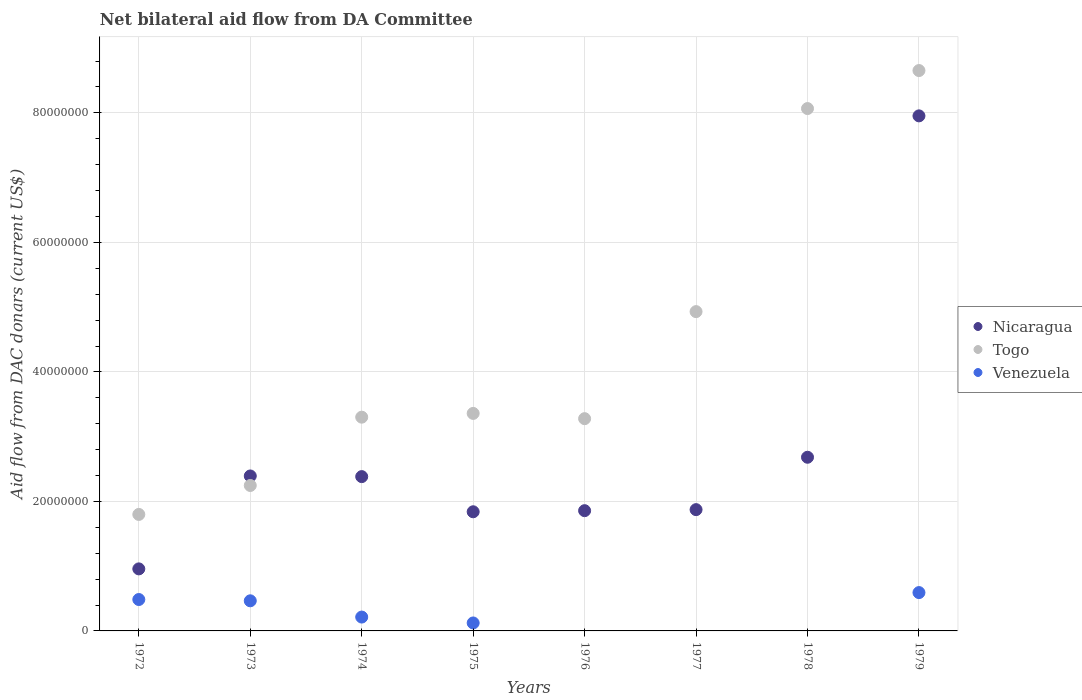Is the number of dotlines equal to the number of legend labels?
Provide a short and direct response. No. What is the aid flow in in Nicaragua in 1975?
Provide a succinct answer. 1.84e+07. Across all years, what is the maximum aid flow in in Nicaragua?
Provide a short and direct response. 7.95e+07. Across all years, what is the minimum aid flow in in Venezuela?
Your answer should be very brief. 0. In which year was the aid flow in in Nicaragua maximum?
Provide a short and direct response. 1979. What is the total aid flow in in Togo in the graph?
Your response must be concise. 3.56e+08. What is the difference between the aid flow in in Togo in 1972 and that in 1976?
Offer a very short reply. -1.48e+07. What is the difference between the aid flow in in Venezuela in 1979 and the aid flow in in Togo in 1972?
Your answer should be very brief. -1.21e+07. What is the average aid flow in in Venezuela per year?
Offer a very short reply. 2.35e+06. In the year 1976, what is the difference between the aid flow in in Togo and aid flow in in Nicaragua?
Give a very brief answer. 1.42e+07. What is the ratio of the aid flow in in Nicaragua in 1973 to that in 1975?
Keep it short and to the point. 1.3. Is the aid flow in in Togo in 1976 less than that in 1977?
Your answer should be compact. Yes. What is the difference between the highest and the second highest aid flow in in Nicaragua?
Provide a short and direct response. 5.27e+07. What is the difference between the highest and the lowest aid flow in in Togo?
Your answer should be compact. 6.86e+07. In how many years, is the aid flow in in Venezuela greater than the average aid flow in in Venezuela taken over all years?
Keep it short and to the point. 3. Is it the case that in every year, the sum of the aid flow in in Venezuela and aid flow in in Nicaragua  is greater than the aid flow in in Togo?
Your response must be concise. No. Does the aid flow in in Venezuela monotonically increase over the years?
Your answer should be compact. No. Is the aid flow in in Venezuela strictly greater than the aid flow in in Nicaragua over the years?
Ensure brevity in your answer.  No. How many dotlines are there?
Offer a terse response. 3. How many years are there in the graph?
Offer a terse response. 8. What is the difference between two consecutive major ticks on the Y-axis?
Give a very brief answer. 2.00e+07. Are the values on the major ticks of Y-axis written in scientific E-notation?
Keep it short and to the point. No. How are the legend labels stacked?
Ensure brevity in your answer.  Vertical. What is the title of the graph?
Keep it short and to the point. Net bilateral aid flow from DA Committee. Does "Lao PDR" appear as one of the legend labels in the graph?
Your answer should be compact. No. What is the label or title of the X-axis?
Ensure brevity in your answer.  Years. What is the label or title of the Y-axis?
Give a very brief answer. Aid flow from DAC donars (current US$). What is the Aid flow from DAC donars (current US$) in Nicaragua in 1972?
Make the answer very short. 9.58e+06. What is the Aid flow from DAC donars (current US$) in Togo in 1972?
Provide a succinct answer. 1.80e+07. What is the Aid flow from DAC donars (current US$) in Venezuela in 1972?
Provide a succinct answer. 4.85e+06. What is the Aid flow from DAC donars (current US$) in Nicaragua in 1973?
Ensure brevity in your answer.  2.39e+07. What is the Aid flow from DAC donars (current US$) of Togo in 1973?
Keep it short and to the point. 2.25e+07. What is the Aid flow from DAC donars (current US$) in Venezuela in 1973?
Give a very brief answer. 4.65e+06. What is the Aid flow from DAC donars (current US$) of Nicaragua in 1974?
Your answer should be very brief. 2.38e+07. What is the Aid flow from DAC donars (current US$) of Togo in 1974?
Give a very brief answer. 3.30e+07. What is the Aid flow from DAC donars (current US$) of Venezuela in 1974?
Make the answer very short. 2.14e+06. What is the Aid flow from DAC donars (current US$) of Nicaragua in 1975?
Your answer should be compact. 1.84e+07. What is the Aid flow from DAC donars (current US$) in Togo in 1975?
Provide a short and direct response. 3.36e+07. What is the Aid flow from DAC donars (current US$) in Venezuela in 1975?
Make the answer very short. 1.23e+06. What is the Aid flow from DAC donars (current US$) of Nicaragua in 1976?
Give a very brief answer. 1.86e+07. What is the Aid flow from DAC donars (current US$) of Togo in 1976?
Offer a very short reply. 3.28e+07. What is the Aid flow from DAC donars (current US$) in Venezuela in 1976?
Keep it short and to the point. 0. What is the Aid flow from DAC donars (current US$) of Nicaragua in 1977?
Your answer should be very brief. 1.87e+07. What is the Aid flow from DAC donars (current US$) in Togo in 1977?
Ensure brevity in your answer.  4.93e+07. What is the Aid flow from DAC donars (current US$) in Venezuela in 1977?
Offer a terse response. 0. What is the Aid flow from DAC donars (current US$) in Nicaragua in 1978?
Give a very brief answer. 2.68e+07. What is the Aid flow from DAC donars (current US$) of Togo in 1978?
Your answer should be compact. 8.07e+07. What is the Aid flow from DAC donars (current US$) of Venezuela in 1978?
Provide a short and direct response. 0. What is the Aid flow from DAC donars (current US$) of Nicaragua in 1979?
Provide a succinct answer. 7.95e+07. What is the Aid flow from DAC donars (current US$) in Togo in 1979?
Offer a very short reply. 8.65e+07. What is the Aid flow from DAC donars (current US$) in Venezuela in 1979?
Provide a short and direct response. 5.92e+06. Across all years, what is the maximum Aid flow from DAC donars (current US$) in Nicaragua?
Provide a succinct answer. 7.95e+07. Across all years, what is the maximum Aid flow from DAC donars (current US$) in Togo?
Your answer should be compact. 8.65e+07. Across all years, what is the maximum Aid flow from DAC donars (current US$) in Venezuela?
Provide a succinct answer. 5.92e+06. Across all years, what is the minimum Aid flow from DAC donars (current US$) in Nicaragua?
Your answer should be very brief. 9.58e+06. Across all years, what is the minimum Aid flow from DAC donars (current US$) of Togo?
Make the answer very short. 1.80e+07. Across all years, what is the minimum Aid flow from DAC donars (current US$) in Venezuela?
Offer a very short reply. 0. What is the total Aid flow from DAC donars (current US$) in Nicaragua in the graph?
Provide a short and direct response. 2.19e+08. What is the total Aid flow from DAC donars (current US$) of Togo in the graph?
Your answer should be very brief. 3.56e+08. What is the total Aid flow from DAC donars (current US$) in Venezuela in the graph?
Provide a short and direct response. 1.88e+07. What is the difference between the Aid flow from DAC donars (current US$) in Nicaragua in 1972 and that in 1973?
Your response must be concise. -1.44e+07. What is the difference between the Aid flow from DAC donars (current US$) of Togo in 1972 and that in 1973?
Your answer should be very brief. -4.47e+06. What is the difference between the Aid flow from DAC donars (current US$) of Nicaragua in 1972 and that in 1974?
Your answer should be compact. -1.42e+07. What is the difference between the Aid flow from DAC donars (current US$) in Togo in 1972 and that in 1974?
Your response must be concise. -1.50e+07. What is the difference between the Aid flow from DAC donars (current US$) of Venezuela in 1972 and that in 1974?
Offer a very short reply. 2.71e+06. What is the difference between the Aid flow from DAC donars (current US$) of Nicaragua in 1972 and that in 1975?
Your response must be concise. -8.82e+06. What is the difference between the Aid flow from DAC donars (current US$) in Togo in 1972 and that in 1975?
Keep it short and to the point. -1.56e+07. What is the difference between the Aid flow from DAC donars (current US$) in Venezuela in 1972 and that in 1975?
Your answer should be compact. 3.62e+06. What is the difference between the Aid flow from DAC donars (current US$) of Nicaragua in 1972 and that in 1976?
Keep it short and to the point. -8.99e+06. What is the difference between the Aid flow from DAC donars (current US$) in Togo in 1972 and that in 1976?
Make the answer very short. -1.48e+07. What is the difference between the Aid flow from DAC donars (current US$) in Nicaragua in 1972 and that in 1977?
Your response must be concise. -9.15e+06. What is the difference between the Aid flow from DAC donars (current US$) in Togo in 1972 and that in 1977?
Your answer should be compact. -3.13e+07. What is the difference between the Aid flow from DAC donars (current US$) of Nicaragua in 1972 and that in 1978?
Give a very brief answer. -1.72e+07. What is the difference between the Aid flow from DAC donars (current US$) of Togo in 1972 and that in 1978?
Give a very brief answer. -6.27e+07. What is the difference between the Aid flow from DAC donars (current US$) in Nicaragua in 1972 and that in 1979?
Provide a short and direct response. -7.00e+07. What is the difference between the Aid flow from DAC donars (current US$) in Togo in 1972 and that in 1979?
Your answer should be very brief. -6.86e+07. What is the difference between the Aid flow from DAC donars (current US$) of Venezuela in 1972 and that in 1979?
Your response must be concise. -1.07e+06. What is the difference between the Aid flow from DAC donars (current US$) of Nicaragua in 1973 and that in 1974?
Ensure brevity in your answer.  1.00e+05. What is the difference between the Aid flow from DAC donars (current US$) of Togo in 1973 and that in 1974?
Ensure brevity in your answer.  -1.06e+07. What is the difference between the Aid flow from DAC donars (current US$) in Venezuela in 1973 and that in 1974?
Provide a short and direct response. 2.51e+06. What is the difference between the Aid flow from DAC donars (current US$) in Nicaragua in 1973 and that in 1975?
Ensure brevity in your answer.  5.53e+06. What is the difference between the Aid flow from DAC donars (current US$) in Togo in 1973 and that in 1975?
Your response must be concise. -1.11e+07. What is the difference between the Aid flow from DAC donars (current US$) in Venezuela in 1973 and that in 1975?
Your answer should be compact. 3.42e+06. What is the difference between the Aid flow from DAC donars (current US$) in Nicaragua in 1973 and that in 1976?
Your answer should be very brief. 5.36e+06. What is the difference between the Aid flow from DAC donars (current US$) in Togo in 1973 and that in 1976?
Your answer should be compact. -1.03e+07. What is the difference between the Aid flow from DAC donars (current US$) in Nicaragua in 1973 and that in 1977?
Offer a very short reply. 5.20e+06. What is the difference between the Aid flow from DAC donars (current US$) of Togo in 1973 and that in 1977?
Provide a succinct answer. -2.68e+07. What is the difference between the Aid flow from DAC donars (current US$) of Nicaragua in 1973 and that in 1978?
Provide a short and direct response. -2.89e+06. What is the difference between the Aid flow from DAC donars (current US$) of Togo in 1973 and that in 1978?
Your answer should be compact. -5.82e+07. What is the difference between the Aid flow from DAC donars (current US$) in Nicaragua in 1973 and that in 1979?
Your response must be concise. -5.56e+07. What is the difference between the Aid flow from DAC donars (current US$) in Togo in 1973 and that in 1979?
Make the answer very short. -6.41e+07. What is the difference between the Aid flow from DAC donars (current US$) of Venezuela in 1973 and that in 1979?
Keep it short and to the point. -1.27e+06. What is the difference between the Aid flow from DAC donars (current US$) of Nicaragua in 1974 and that in 1975?
Provide a succinct answer. 5.43e+06. What is the difference between the Aid flow from DAC donars (current US$) in Togo in 1974 and that in 1975?
Offer a very short reply. -5.80e+05. What is the difference between the Aid flow from DAC donars (current US$) of Venezuela in 1974 and that in 1975?
Make the answer very short. 9.10e+05. What is the difference between the Aid flow from DAC donars (current US$) in Nicaragua in 1974 and that in 1976?
Keep it short and to the point. 5.26e+06. What is the difference between the Aid flow from DAC donars (current US$) in Nicaragua in 1974 and that in 1977?
Keep it short and to the point. 5.10e+06. What is the difference between the Aid flow from DAC donars (current US$) in Togo in 1974 and that in 1977?
Keep it short and to the point. -1.63e+07. What is the difference between the Aid flow from DAC donars (current US$) in Nicaragua in 1974 and that in 1978?
Offer a terse response. -2.99e+06. What is the difference between the Aid flow from DAC donars (current US$) in Togo in 1974 and that in 1978?
Keep it short and to the point. -4.77e+07. What is the difference between the Aid flow from DAC donars (current US$) in Nicaragua in 1974 and that in 1979?
Your answer should be very brief. -5.57e+07. What is the difference between the Aid flow from DAC donars (current US$) of Togo in 1974 and that in 1979?
Your response must be concise. -5.35e+07. What is the difference between the Aid flow from DAC donars (current US$) in Venezuela in 1974 and that in 1979?
Your response must be concise. -3.78e+06. What is the difference between the Aid flow from DAC donars (current US$) of Togo in 1975 and that in 1976?
Your answer should be compact. 8.10e+05. What is the difference between the Aid flow from DAC donars (current US$) in Nicaragua in 1975 and that in 1977?
Offer a terse response. -3.30e+05. What is the difference between the Aid flow from DAC donars (current US$) of Togo in 1975 and that in 1977?
Provide a short and direct response. -1.57e+07. What is the difference between the Aid flow from DAC donars (current US$) in Nicaragua in 1975 and that in 1978?
Make the answer very short. -8.42e+06. What is the difference between the Aid flow from DAC donars (current US$) of Togo in 1975 and that in 1978?
Keep it short and to the point. -4.71e+07. What is the difference between the Aid flow from DAC donars (current US$) of Nicaragua in 1975 and that in 1979?
Make the answer very short. -6.11e+07. What is the difference between the Aid flow from DAC donars (current US$) of Togo in 1975 and that in 1979?
Offer a terse response. -5.30e+07. What is the difference between the Aid flow from DAC donars (current US$) in Venezuela in 1975 and that in 1979?
Ensure brevity in your answer.  -4.69e+06. What is the difference between the Aid flow from DAC donars (current US$) of Togo in 1976 and that in 1977?
Make the answer very short. -1.65e+07. What is the difference between the Aid flow from DAC donars (current US$) in Nicaragua in 1976 and that in 1978?
Keep it short and to the point. -8.25e+06. What is the difference between the Aid flow from DAC donars (current US$) of Togo in 1976 and that in 1978?
Provide a short and direct response. -4.79e+07. What is the difference between the Aid flow from DAC donars (current US$) of Nicaragua in 1976 and that in 1979?
Provide a succinct answer. -6.10e+07. What is the difference between the Aid flow from DAC donars (current US$) in Togo in 1976 and that in 1979?
Keep it short and to the point. -5.38e+07. What is the difference between the Aid flow from DAC donars (current US$) in Nicaragua in 1977 and that in 1978?
Your answer should be compact. -8.09e+06. What is the difference between the Aid flow from DAC donars (current US$) in Togo in 1977 and that in 1978?
Ensure brevity in your answer.  -3.14e+07. What is the difference between the Aid flow from DAC donars (current US$) of Nicaragua in 1977 and that in 1979?
Provide a succinct answer. -6.08e+07. What is the difference between the Aid flow from DAC donars (current US$) in Togo in 1977 and that in 1979?
Provide a short and direct response. -3.72e+07. What is the difference between the Aid flow from DAC donars (current US$) of Nicaragua in 1978 and that in 1979?
Offer a very short reply. -5.27e+07. What is the difference between the Aid flow from DAC donars (current US$) of Togo in 1978 and that in 1979?
Your answer should be very brief. -5.87e+06. What is the difference between the Aid flow from DAC donars (current US$) of Nicaragua in 1972 and the Aid flow from DAC donars (current US$) of Togo in 1973?
Give a very brief answer. -1.29e+07. What is the difference between the Aid flow from DAC donars (current US$) in Nicaragua in 1972 and the Aid flow from DAC donars (current US$) in Venezuela in 1973?
Provide a short and direct response. 4.93e+06. What is the difference between the Aid flow from DAC donars (current US$) of Togo in 1972 and the Aid flow from DAC donars (current US$) of Venezuela in 1973?
Offer a terse response. 1.33e+07. What is the difference between the Aid flow from DAC donars (current US$) of Nicaragua in 1972 and the Aid flow from DAC donars (current US$) of Togo in 1974?
Your answer should be compact. -2.34e+07. What is the difference between the Aid flow from DAC donars (current US$) of Nicaragua in 1972 and the Aid flow from DAC donars (current US$) of Venezuela in 1974?
Provide a succinct answer. 7.44e+06. What is the difference between the Aid flow from DAC donars (current US$) in Togo in 1972 and the Aid flow from DAC donars (current US$) in Venezuela in 1974?
Provide a short and direct response. 1.58e+07. What is the difference between the Aid flow from DAC donars (current US$) in Nicaragua in 1972 and the Aid flow from DAC donars (current US$) in Togo in 1975?
Provide a short and direct response. -2.40e+07. What is the difference between the Aid flow from DAC donars (current US$) of Nicaragua in 1972 and the Aid flow from DAC donars (current US$) of Venezuela in 1975?
Provide a succinct answer. 8.35e+06. What is the difference between the Aid flow from DAC donars (current US$) of Togo in 1972 and the Aid flow from DAC donars (current US$) of Venezuela in 1975?
Keep it short and to the point. 1.68e+07. What is the difference between the Aid flow from DAC donars (current US$) of Nicaragua in 1972 and the Aid flow from DAC donars (current US$) of Togo in 1976?
Keep it short and to the point. -2.32e+07. What is the difference between the Aid flow from DAC donars (current US$) in Nicaragua in 1972 and the Aid flow from DAC donars (current US$) in Togo in 1977?
Keep it short and to the point. -3.97e+07. What is the difference between the Aid flow from DAC donars (current US$) in Nicaragua in 1972 and the Aid flow from DAC donars (current US$) in Togo in 1978?
Provide a short and direct response. -7.11e+07. What is the difference between the Aid flow from DAC donars (current US$) of Nicaragua in 1972 and the Aid flow from DAC donars (current US$) of Togo in 1979?
Keep it short and to the point. -7.70e+07. What is the difference between the Aid flow from DAC donars (current US$) in Nicaragua in 1972 and the Aid flow from DAC donars (current US$) in Venezuela in 1979?
Ensure brevity in your answer.  3.66e+06. What is the difference between the Aid flow from DAC donars (current US$) of Togo in 1972 and the Aid flow from DAC donars (current US$) of Venezuela in 1979?
Provide a succinct answer. 1.21e+07. What is the difference between the Aid flow from DAC donars (current US$) of Nicaragua in 1973 and the Aid flow from DAC donars (current US$) of Togo in 1974?
Offer a very short reply. -9.08e+06. What is the difference between the Aid flow from DAC donars (current US$) in Nicaragua in 1973 and the Aid flow from DAC donars (current US$) in Venezuela in 1974?
Your answer should be very brief. 2.18e+07. What is the difference between the Aid flow from DAC donars (current US$) in Togo in 1973 and the Aid flow from DAC donars (current US$) in Venezuela in 1974?
Ensure brevity in your answer.  2.03e+07. What is the difference between the Aid flow from DAC donars (current US$) of Nicaragua in 1973 and the Aid flow from DAC donars (current US$) of Togo in 1975?
Give a very brief answer. -9.66e+06. What is the difference between the Aid flow from DAC donars (current US$) in Nicaragua in 1973 and the Aid flow from DAC donars (current US$) in Venezuela in 1975?
Offer a terse response. 2.27e+07. What is the difference between the Aid flow from DAC donars (current US$) of Togo in 1973 and the Aid flow from DAC donars (current US$) of Venezuela in 1975?
Ensure brevity in your answer.  2.12e+07. What is the difference between the Aid flow from DAC donars (current US$) of Nicaragua in 1973 and the Aid flow from DAC donars (current US$) of Togo in 1976?
Offer a terse response. -8.85e+06. What is the difference between the Aid flow from DAC donars (current US$) of Nicaragua in 1973 and the Aid flow from DAC donars (current US$) of Togo in 1977?
Ensure brevity in your answer.  -2.54e+07. What is the difference between the Aid flow from DAC donars (current US$) of Nicaragua in 1973 and the Aid flow from DAC donars (current US$) of Togo in 1978?
Provide a short and direct response. -5.67e+07. What is the difference between the Aid flow from DAC donars (current US$) in Nicaragua in 1973 and the Aid flow from DAC donars (current US$) in Togo in 1979?
Offer a terse response. -6.26e+07. What is the difference between the Aid flow from DAC donars (current US$) in Nicaragua in 1973 and the Aid flow from DAC donars (current US$) in Venezuela in 1979?
Offer a very short reply. 1.80e+07. What is the difference between the Aid flow from DAC donars (current US$) of Togo in 1973 and the Aid flow from DAC donars (current US$) of Venezuela in 1979?
Offer a very short reply. 1.65e+07. What is the difference between the Aid flow from DAC donars (current US$) in Nicaragua in 1974 and the Aid flow from DAC donars (current US$) in Togo in 1975?
Keep it short and to the point. -9.76e+06. What is the difference between the Aid flow from DAC donars (current US$) in Nicaragua in 1974 and the Aid flow from DAC donars (current US$) in Venezuela in 1975?
Your response must be concise. 2.26e+07. What is the difference between the Aid flow from DAC donars (current US$) in Togo in 1974 and the Aid flow from DAC donars (current US$) in Venezuela in 1975?
Give a very brief answer. 3.18e+07. What is the difference between the Aid flow from DAC donars (current US$) of Nicaragua in 1974 and the Aid flow from DAC donars (current US$) of Togo in 1976?
Your answer should be very brief. -8.95e+06. What is the difference between the Aid flow from DAC donars (current US$) of Nicaragua in 1974 and the Aid flow from DAC donars (current US$) of Togo in 1977?
Your answer should be very brief. -2.55e+07. What is the difference between the Aid flow from DAC donars (current US$) of Nicaragua in 1974 and the Aid flow from DAC donars (current US$) of Togo in 1978?
Your answer should be compact. -5.68e+07. What is the difference between the Aid flow from DAC donars (current US$) of Nicaragua in 1974 and the Aid flow from DAC donars (current US$) of Togo in 1979?
Your answer should be very brief. -6.27e+07. What is the difference between the Aid flow from DAC donars (current US$) in Nicaragua in 1974 and the Aid flow from DAC donars (current US$) in Venezuela in 1979?
Ensure brevity in your answer.  1.79e+07. What is the difference between the Aid flow from DAC donars (current US$) in Togo in 1974 and the Aid flow from DAC donars (current US$) in Venezuela in 1979?
Provide a short and direct response. 2.71e+07. What is the difference between the Aid flow from DAC donars (current US$) of Nicaragua in 1975 and the Aid flow from DAC donars (current US$) of Togo in 1976?
Ensure brevity in your answer.  -1.44e+07. What is the difference between the Aid flow from DAC donars (current US$) in Nicaragua in 1975 and the Aid flow from DAC donars (current US$) in Togo in 1977?
Offer a terse response. -3.09e+07. What is the difference between the Aid flow from DAC donars (current US$) of Nicaragua in 1975 and the Aid flow from DAC donars (current US$) of Togo in 1978?
Provide a short and direct response. -6.23e+07. What is the difference between the Aid flow from DAC donars (current US$) in Nicaragua in 1975 and the Aid flow from DAC donars (current US$) in Togo in 1979?
Your answer should be compact. -6.81e+07. What is the difference between the Aid flow from DAC donars (current US$) in Nicaragua in 1975 and the Aid flow from DAC donars (current US$) in Venezuela in 1979?
Keep it short and to the point. 1.25e+07. What is the difference between the Aid flow from DAC donars (current US$) of Togo in 1975 and the Aid flow from DAC donars (current US$) of Venezuela in 1979?
Ensure brevity in your answer.  2.77e+07. What is the difference between the Aid flow from DAC donars (current US$) of Nicaragua in 1976 and the Aid flow from DAC donars (current US$) of Togo in 1977?
Ensure brevity in your answer.  -3.07e+07. What is the difference between the Aid flow from DAC donars (current US$) in Nicaragua in 1976 and the Aid flow from DAC donars (current US$) in Togo in 1978?
Give a very brief answer. -6.21e+07. What is the difference between the Aid flow from DAC donars (current US$) of Nicaragua in 1976 and the Aid flow from DAC donars (current US$) of Togo in 1979?
Make the answer very short. -6.80e+07. What is the difference between the Aid flow from DAC donars (current US$) in Nicaragua in 1976 and the Aid flow from DAC donars (current US$) in Venezuela in 1979?
Give a very brief answer. 1.26e+07. What is the difference between the Aid flow from DAC donars (current US$) in Togo in 1976 and the Aid flow from DAC donars (current US$) in Venezuela in 1979?
Provide a succinct answer. 2.69e+07. What is the difference between the Aid flow from DAC donars (current US$) of Nicaragua in 1977 and the Aid flow from DAC donars (current US$) of Togo in 1978?
Ensure brevity in your answer.  -6.19e+07. What is the difference between the Aid flow from DAC donars (current US$) of Nicaragua in 1977 and the Aid flow from DAC donars (current US$) of Togo in 1979?
Provide a succinct answer. -6.78e+07. What is the difference between the Aid flow from DAC donars (current US$) in Nicaragua in 1977 and the Aid flow from DAC donars (current US$) in Venezuela in 1979?
Keep it short and to the point. 1.28e+07. What is the difference between the Aid flow from DAC donars (current US$) of Togo in 1977 and the Aid flow from DAC donars (current US$) of Venezuela in 1979?
Offer a very short reply. 4.34e+07. What is the difference between the Aid flow from DAC donars (current US$) of Nicaragua in 1978 and the Aid flow from DAC donars (current US$) of Togo in 1979?
Provide a short and direct response. -5.97e+07. What is the difference between the Aid flow from DAC donars (current US$) in Nicaragua in 1978 and the Aid flow from DAC donars (current US$) in Venezuela in 1979?
Provide a succinct answer. 2.09e+07. What is the difference between the Aid flow from DAC donars (current US$) in Togo in 1978 and the Aid flow from DAC donars (current US$) in Venezuela in 1979?
Provide a succinct answer. 7.48e+07. What is the average Aid flow from DAC donars (current US$) in Nicaragua per year?
Keep it short and to the point. 2.74e+07. What is the average Aid flow from DAC donars (current US$) in Togo per year?
Offer a very short reply. 4.45e+07. What is the average Aid flow from DAC donars (current US$) of Venezuela per year?
Your answer should be compact. 2.35e+06. In the year 1972, what is the difference between the Aid flow from DAC donars (current US$) of Nicaragua and Aid flow from DAC donars (current US$) of Togo?
Provide a succinct answer. -8.41e+06. In the year 1972, what is the difference between the Aid flow from DAC donars (current US$) in Nicaragua and Aid flow from DAC donars (current US$) in Venezuela?
Give a very brief answer. 4.73e+06. In the year 1972, what is the difference between the Aid flow from DAC donars (current US$) in Togo and Aid flow from DAC donars (current US$) in Venezuela?
Keep it short and to the point. 1.31e+07. In the year 1973, what is the difference between the Aid flow from DAC donars (current US$) in Nicaragua and Aid flow from DAC donars (current US$) in Togo?
Keep it short and to the point. 1.47e+06. In the year 1973, what is the difference between the Aid flow from DAC donars (current US$) of Nicaragua and Aid flow from DAC donars (current US$) of Venezuela?
Ensure brevity in your answer.  1.93e+07. In the year 1973, what is the difference between the Aid flow from DAC donars (current US$) of Togo and Aid flow from DAC donars (current US$) of Venezuela?
Your answer should be very brief. 1.78e+07. In the year 1974, what is the difference between the Aid flow from DAC donars (current US$) in Nicaragua and Aid flow from DAC donars (current US$) in Togo?
Keep it short and to the point. -9.18e+06. In the year 1974, what is the difference between the Aid flow from DAC donars (current US$) of Nicaragua and Aid flow from DAC donars (current US$) of Venezuela?
Provide a short and direct response. 2.17e+07. In the year 1974, what is the difference between the Aid flow from DAC donars (current US$) in Togo and Aid flow from DAC donars (current US$) in Venezuela?
Keep it short and to the point. 3.09e+07. In the year 1975, what is the difference between the Aid flow from DAC donars (current US$) in Nicaragua and Aid flow from DAC donars (current US$) in Togo?
Offer a terse response. -1.52e+07. In the year 1975, what is the difference between the Aid flow from DAC donars (current US$) of Nicaragua and Aid flow from DAC donars (current US$) of Venezuela?
Give a very brief answer. 1.72e+07. In the year 1975, what is the difference between the Aid flow from DAC donars (current US$) of Togo and Aid flow from DAC donars (current US$) of Venezuela?
Your response must be concise. 3.24e+07. In the year 1976, what is the difference between the Aid flow from DAC donars (current US$) in Nicaragua and Aid flow from DAC donars (current US$) in Togo?
Give a very brief answer. -1.42e+07. In the year 1977, what is the difference between the Aid flow from DAC donars (current US$) of Nicaragua and Aid flow from DAC donars (current US$) of Togo?
Keep it short and to the point. -3.06e+07. In the year 1978, what is the difference between the Aid flow from DAC donars (current US$) of Nicaragua and Aid flow from DAC donars (current US$) of Togo?
Offer a very short reply. -5.38e+07. In the year 1979, what is the difference between the Aid flow from DAC donars (current US$) in Nicaragua and Aid flow from DAC donars (current US$) in Togo?
Offer a very short reply. -7.00e+06. In the year 1979, what is the difference between the Aid flow from DAC donars (current US$) of Nicaragua and Aid flow from DAC donars (current US$) of Venezuela?
Your answer should be compact. 7.36e+07. In the year 1979, what is the difference between the Aid flow from DAC donars (current US$) of Togo and Aid flow from DAC donars (current US$) of Venezuela?
Your answer should be compact. 8.06e+07. What is the ratio of the Aid flow from DAC donars (current US$) in Nicaragua in 1972 to that in 1973?
Offer a terse response. 0.4. What is the ratio of the Aid flow from DAC donars (current US$) of Togo in 1972 to that in 1973?
Ensure brevity in your answer.  0.8. What is the ratio of the Aid flow from DAC donars (current US$) of Venezuela in 1972 to that in 1973?
Offer a terse response. 1.04. What is the ratio of the Aid flow from DAC donars (current US$) in Nicaragua in 1972 to that in 1974?
Your answer should be compact. 0.4. What is the ratio of the Aid flow from DAC donars (current US$) of Togo in 1972 to that in 1974?
Ensure brevity in your answer.  0.55. What is the ratio of the Aid flow from DAC donars (current US$) of Venezuela in 1972 to that in 1974?
Ensure brevity in your answer.  2.27. What is the ratio of the Aid flow from DAC donars (current US$) of Nicaragua in 1972 to that in 1975?
Provide a succinct answer. 0.52. What is the ratio of the Aid flow from DAC donars (current US$) of Togo in 1972 to that in 1975?
Offer a terse response. 0.54. What is the ratio of the Aid flow from DAC donars (current US$) in Venezuela in 1972 to that in 1975?
Provide a short and direct response. 3.94. What is the ratio of the Aid flow from DAC donars (current US$) in Nicaragua in 1972 to that in 1976?
Offer a very short reply. 0.52. What is the ratio of the Aid flow from DAC donars (current US$) in Togo in 1972 to that in 1976?
Offer a terse response. 0.55. What is the ratio of the Aid flow from DAC donars (current US$) of Nicaragua in 1972 to that in 1977?
Offer a terse response. 0.51. What is the ratio of the Aid flow from DAC donars (current US$) of Togo in 1972 to that in 1977?
Your response must be concise. 0.36. What is the ratio of the Aid flow from DAC donars (current US$) of Nicaragua in 1972 to that in 1978?
Keep it short and to the point. 0.36. What is the ratio of the Aid flow from DAC donars (current US$) of Togo in 1972 to that in 1978?
Offer a very short reply. 0.22. What is the ratio of the Aid flow from DAC donars (current US$) in Nicaragua in 1972 to that in 1979?
Your response must be concise. 0.12. What is the ratio of the Aid flow from DAC donars (current US$) in Togo in 1972 to that in 1979?
Make the answer very short. 0.21. What is the ratio of the Aid flow from DAC donars (current US$) of Venezuela in 1972 to that in 1979?
Provide a short and direct response. 0.82. What is the ratio of the Aid flow from DAC donars (current US$) in Togo in 1973 to that in 1974?
Provide a succinct answer. 0.68. What is the ratio of the Aid flow from DAC donars (current US$) in Venezuela in 1973 to that in 1974?
Offer a very short reply. 2.17. What is the ratio of the Aid flow from DAC donars (current US$) in Nicaragua in 1973 to that in 1975?
Keep it short and to the point. 1.3. What is the ratio of the Aid flow from DAC donars (current US$) of Togo in 1973 to that in 1975?
Provide a succinct answer. 0.67. What is the ratio of the Aid flow from DAC donars (current US$) in Venezuela in 1973 to that in 1975?
Give a very brief answer. 3.78. What is the ratio of the Aid flow from DAC donars (current US$) of Nicaragua in 1973 to that in 1976?
Your answer should be compact. 1.29. What is the ratio of the Aid flow from DAC donars (current US$) of Togo in 1973 to that in 1976?
Ensure brevity in your answer.  0.69. What is the ratio of the Aid flow from DAC donars (current US$) in Nicaragua in 1973 to that in 1977?
Provide a short and direct response. 1.28. What is the ratio of the Aid flow from DAC donars (current US$) in Togo in 1973 to that in 1977?
Offer a very short reply. 0.46. What is the ratio of the Aid flow from DAC donars (current US$) in Nicaragua in 1973 to that in 1978?
Offer a terse response. 0.89. What is the ratio of the Aid flow from DAC donars (current US$) of Togo in 1973 to that in 1978?
Offer a very short reply. 0.28. What is the ratio of the Aid flow from DAC donars (current US$) of Nicaragua in 1973 to that in 1979?
Make the answer very short. 0.3. What is the ratio of the Aid flow from DAC donars (current US$) in Togo in 1973 to that in 1979?
Your response must be concise. 0.26. What is the ratio of the Aid flow from DAC donars (current US$) of Venezuela in 1973 to that in 1979?
Offer a very short reply. 0.79. What is the ratio of the Aid flow from DAC donars (current US$) in Nicaragua in 1974 to that in 1975?
Provide a short and direct response. 1.3. What is the ratio of the Aid flow from DAC donars (current US$) in Togo in 1974 to that in 1975?
Ensure brevity in your answer.  0.98. What is the ratio of the Aid flow from DAC donars (current US$) of Venezuela in 1974 to that in 1975?
Your answer should be very brief. 1.74. What is the ratio of the Aid flow from DAC donars (current US$) of Nicaragua in 1974 to that in 1976?
Your answer should be very brief. 1.28. What is the ratio of the Aid flow from DAC donars (current US$) of Togo in 1974 to that in 1976?
Your response must be concise. 1.01. What is the ratio of the Aid flow from DAC donars (current US$) in Nicaragua in 1974 to that in 1977?
Your answer should be very brief. 1.27. What is the ratio of the Aid flow from DAC donars (current US$) in Togo in 1974 to that in 1977?
Your response must be concise. 0.67. What is the ratio of the Aid flow from DAC donars (current US$) in Nicaragua in 1974 to that in 1978?
Give a very brief answer. 0.89. What is the ratio of the Aid flow from DAC donars (current US$) of Togo in 1974 to that in 1978?
Offer a terse response. 0.41. What is the ratio of the Aid flow from DAC donars (current US$) of Nicaragua in 1974 to that in 1979?
Your response must be concise. 0.3. What is the ratio of the Aid flow from DAC donars (current US$) of Togo in 1974 to that in 1979?
Your answer should be very brief. 0.38. What is the ratio of the Aid flow from DAC donars (current US$) of Venezuela in 1974 to that in 1979?
Keep it short and to the point. 0.36. What is the ratio of the Aid flow from DAC donars (current US$) of Nicaragua in 1975 to that in 1976?
Offer a terse response. 0.99. What is the ratio of the Aid flow from DAC donars (current US$) of Togo in 1975 to that in 1976?
Provide a succinct answer. 1.02. What is the ratio of the Aid flow from DAC donars (current US$) of Nicaragua in 1975 to that in 1977?
Provide a succinct answer. 0.98. What is the ratio of the Aid flow from DAC donars (current US$) in Togo in 1975 to that in 1977?
Your answer should be compact. 0.68. What is the ratio of the Aid flow from DAC donars (current US$) in Nicaragua in 1975 to that in 1978?
Offer a very short reply. 0.69. What is the ratio of the Aid flow from DAC donars (current US$) in Togo in 1975 to that in 1978?
Your answer should be very brief. 0.42. What is the ratio of the Aid flow from DAC donars (current US$) in Nicaragua in 1975 to that in 1979?
Your answer should be compact. 0.23. What is the ratio of the Aid flow from DAC donars (current US$) of Togo in 1975 to that in 1979?
Give a very brief answer. 0.39. What is the ratio of the Aid flow from DAC donars (current US$) in Venezuela in 1975 to that in 1979?
Provide a succinct answer. 0.21. What is the ratio of the Aid flow from DAC donars (current US$) in Nicaragua in 1976 to that in 1977?
Offer a very short reply. 0.99. What is the ratio of the Aid flow from DAC donars (current US$) of Togo in 1976 to that in 1977?
Provide a succinct answer. 0.66. What is the ratio of the Aid flow from DAC donars (current US$) of Nicaragua in 1976 to that in 1978?
Provide a succinct answer. 0.69. What is the ratio of the Aid flow from DAC donars (current US$) in Togo in 1976 to that in 1978?
Keep it short and to the point. 0.41. What is the ratio of the Aid flow from DAC donars (current US$) in Nicaragua in 1976 to that in 1979?
Ensure brevity in your answer.  0.23. What is the ratio of the Aid flow from DAC donars (current US$) in Togo in 1976 to that in 1979?
Your answer should be very brief. 0.38. What is the ratio of the Aid flow from DAC donars (current US$) of Nicaragua in 1977 to that in 1978?
Provide a short and direct response. 0.7. What is the ratio of the Aid flow from DAC donars (current US$) of Togo in 1977 to that in 1978?
Provide a succinct answer. 0.61. What is the ratio of the Aid flow from DAC donars (current US$) in Nicaragua in 1977 to that in 1979?
Provide a short and direct response. 0.24. What is the ratio of the Aid flow from DAC donars (current US$) in Togo in 1977 to that in 1979?
Your answer should be compact. 0.57. What is the ratio of the Aid flow from DAC donars (current US$) in Nicaragua in 1978 to that in 1979?
Keep it short and to the point. 0.34. What is the ratio of the Aid flow from DAC donars (current US$) in Togo in 1978 to that in 1979?
Ensure brevity in your answer.  0.93. What is the difference between the highest and the second highest Aid flow from DAC donars (current US$) in Nicaragua?
Your response must be concise. 5.27e+07. What is the difference between the highest and the second highest Aid flow from DAC donars (current US$) of Togo?
Give a very brief answer. 5.87e+06. What is the difference between the highest and the second highest Aid flow from DAC donars (current US$) of Venezuela?
Your answer should be very brief. 1.07e+06. What is the difference between the highest and the lowest Aid flow from DAC donars (current US$) of Nicaragua?
Ensure brevity in your answer.  7.00e+07. What is the difference between the highest and the lowest Aid flow from DAC donars (current US$) in Togo?
Your answer should be very brief. 6.86e+07. What is the difference between the highest and the lowest Aid flow from DAC donars (current US$) of Venezuela?
Give a very brief answer. 5.92e+06. 